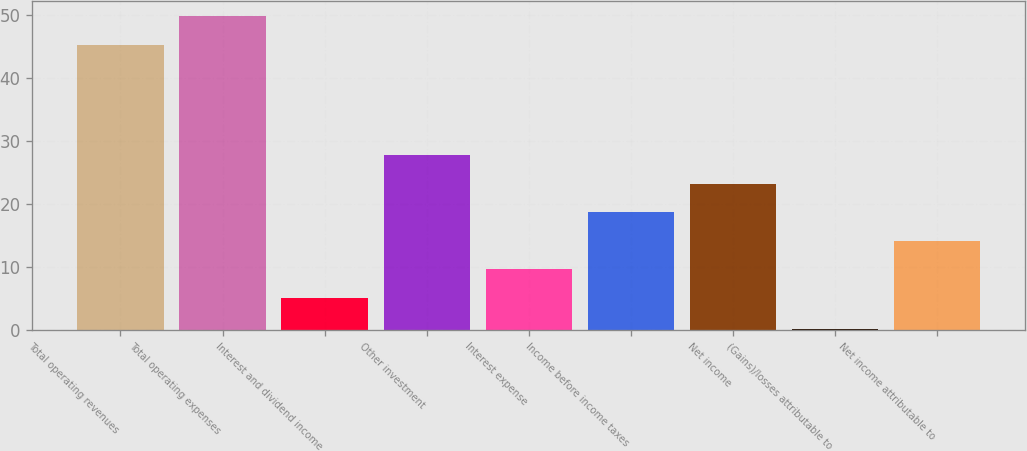Convert chart. <chart><loc_0><loc_0><loc_500><loc_500><bar_chart><fcel>Total operating revenues<fcel>Total operating expenses<fcel>Interest and dividend income<fcel>Other investment<fcel>Interest expense<fcel>Income before income taxes<fcel>Net income<fcel>(Gains)/losses attributable to<fcel>Net income attributable to<nl><fcel>45.3<fcel>49.82<fcel>5.1<fcel>27.7<fcel>9.62<fcel>18.66<fcel>23.18<fcel>0.1<fcel>14.14<nl></chart> 